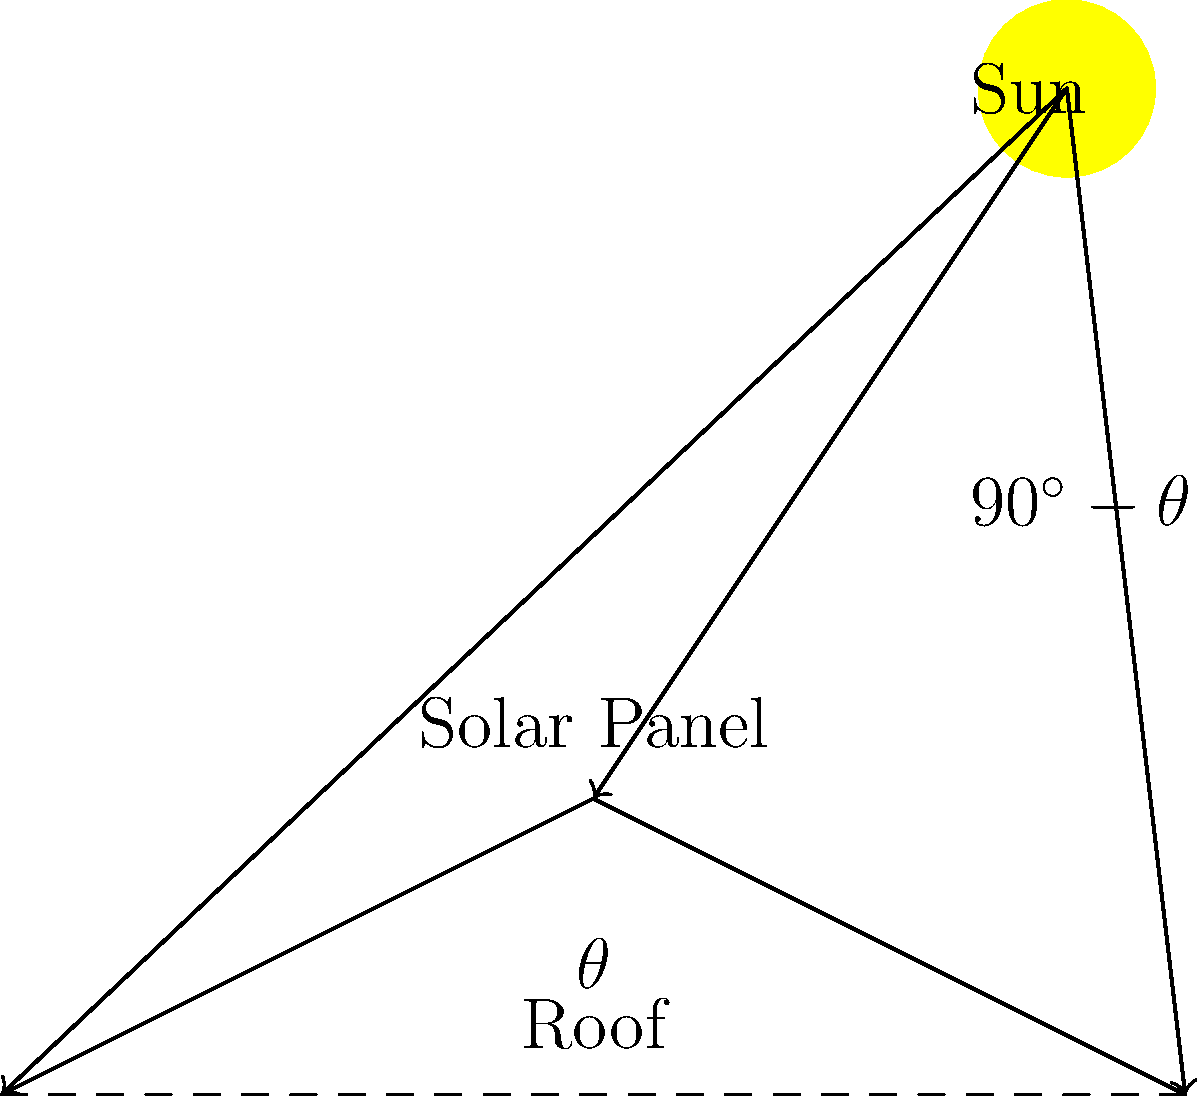A solar panel is installed on a roof with a pitch angle of $\theta$ degrees from the horizontal. If the sun's rays make an angle of $(90^\circ - \theta)$ with the roof surface, and the solar panel has a rated efficiency of 20% under direct sunlight, calculate the actual efficiency of the panel in this position. Assume that the efficiency is directly proportional to the cosine of the angle between the sun's rays and the perpendicular to the panel surface. To solve this problem, we'll follow these steps:

1) First, we need to find the angle between the sun's rays and the perpendicular to the panel surface. Let's call this angle $\phi$.

2) We know that the sun's rays make an angle of $(90^\circ - \theta)$ with the roof surface. The perpendicular to the roof surface is at an angle $\theta$ to the vertical. Therefore:

   $\phi = (90^\circ - \theta) - \theta = 90^\circ - 2\theta$

3) The efficiency is proportional to the cosine of this angle. So if $E$ is the actual efficiency and $E_0$ is the rated efficiency (20%):

   $E = E_0 \cos(\phi)$

4) Substituting the expression for $\phi$:

   $E = E_0 \cos(90^\circ - 2\theta) = E_0 \sin(2\theta)$

5) Now we can calculate:

   $E = 0.20 \sin(2\theta)$

This gives us the actual efficiency as a function of the roof pitch angle $\theta$.
Answer: $E = 0.20 \sin(2\theta)$ 